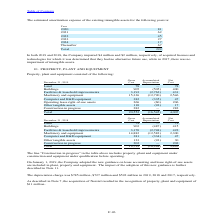According to Stmicroelectronics's financial document, What were the new guidelines adopted by the company on January 1, 2019? On January 1, 2019, the Company adopted the new guidance on lease accounting and lease right-of-use assets are included in plant, property and equipment.. The document states: "On January 1, 2019, the Company adopted the new guidance on lease accounting and lease right-of-use assets are included in plant, property and equipme..." Also, How much recognition of property, plant and equipment led to the acquisition of Norstel? According to the financial document, $11 million.. The relevant text states: "he recognition of property, plant and equipment of $11 million...." Also, What were the depreciation charge for 2019, 2018 and 2017? The depreciation charge was $785 million, $727 million and $592 million in 2019, 2018 and 2017, respectively.. The document states: "The depreciation charge was $785 million, $727 million and $592 million in 2019, 2018 and 2017, respectively...." Also, can you calculate: What is the average Gross Cost? To answer this question, I need to perform calculations using the financial data. The calculation is: (20,552+19,739) / 2, which equals 20145.5 (in millions). This is based on the information: "Total 20,552 (16,545) 4,007 Total 19,739 (16,244) 3,495..." The key data points involved are: 19,739, 20,552. Also, can you calculate: What is the average Accumulated Depreciation? To answer this question, I need to perform calculations using the financial data. The calculation is: (16,545+16,244) / 2, which equals 16394.5 (in millions). This is based on the information: "Total 19,739 (16,244) 3,495 Total 20,552 (16,545) 4,007..." The key data points involved are: 16,244, 16,545. Also, can you calculate: What is the average Net Cost? To answer this question, I need to perform calculations using the financial data. The calculation is: (4,007+3,495) / 2, which equals 3751 (in millions). This is based on the information: "Total 19,739 (16,244) 3,495 Total 20,552 (16,545) 4,007..." The key data points involved are: 3,495, 4,007. 